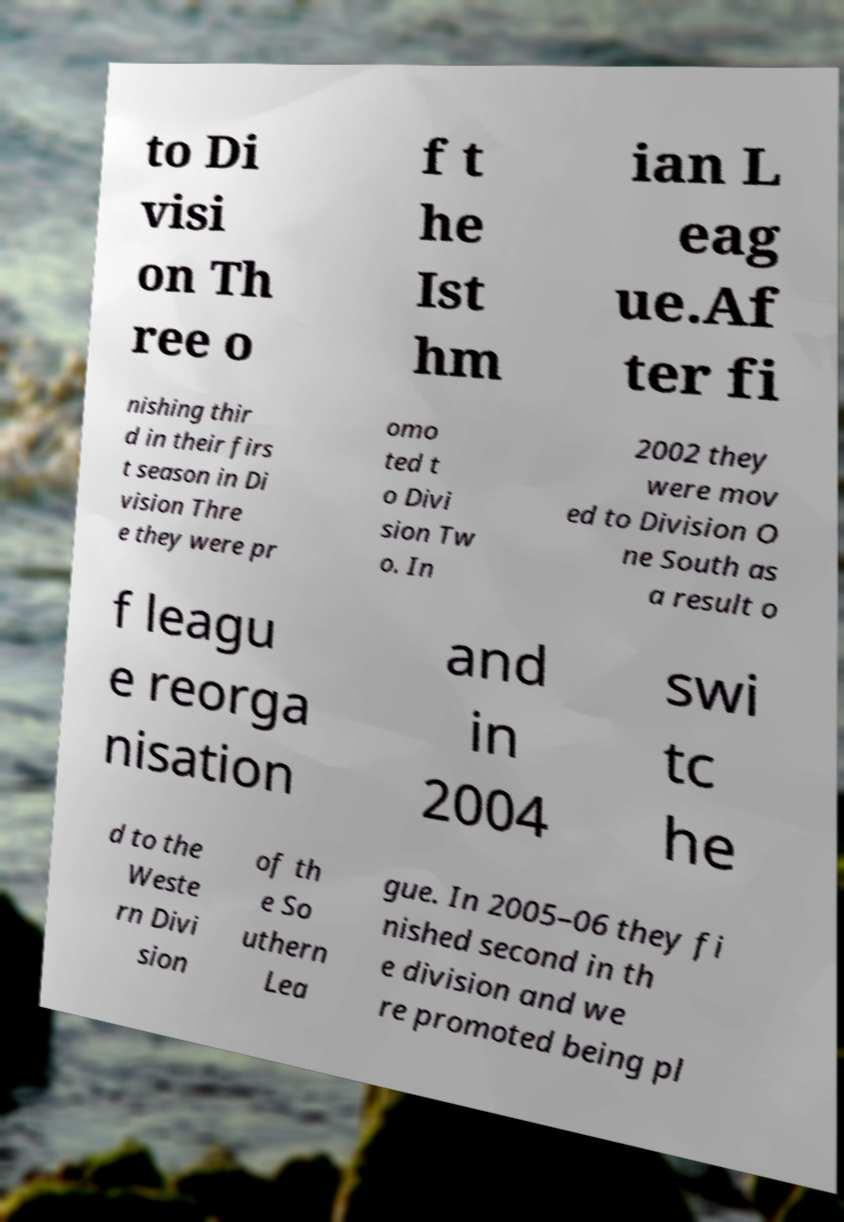For documentation purposes, I need the text within this image transcribed. Could you provide that? to Di visi on Th ree o f t he Ist hm ian L eag ue.Af ter fi nishing thir d in their firs t season in Di vision Thre e they were pr omo ted t o Divi sion Tw o. In 2002 they were mov ed to Division O ne South as a result o f leagu e reorga nisation and in 2004 swi tc he d to the Weste rn Divi sion of th e So uthern Lea gue. In 2005–06 they fi nished second in th e division and we re promoted being pl 